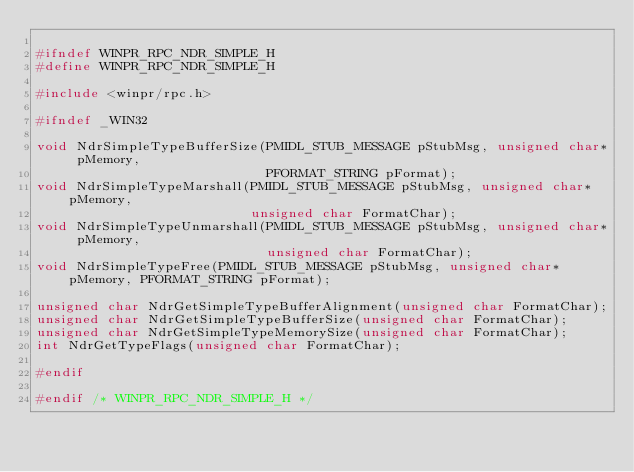<code> <loc_0><loc_0><loc_500><loc_500><_C_>
#ifndef WINPR_RPC_NDR_SIMPLE_H
#define WINPR_RPC_NDR_SIMPLE_H

#include <winpr/rpc.h>

#ifndef _WIN32

void NdrSimpleTypeBufferSize(PMIDL_STUB_MESSAGE pStubMsg, unsigned char* pMemory,
                             PFORMAT_STRING pFormat);
void NdrSimpleTypeMarshall(PMIDL_STUB_MESSAGE pStubMsg, unsigned char* pMemory,
                           unsigned char FormatChar);
void NdrSimpleTypeUnmarshall(PMIDL_STUB_MESSAGE pStubMsg, unsigned char* pMemory,
                             unsigned char FormatChar);
void NdrSimpleTypeFree(PMIDL_STUB_MESSAGE pStubMsg, unsigned char* pMemory, PFORMAT_STRING pFormat);

unsigned char NdrGetSimpleTypeBufferAlignment(unsigned char FormatChar);
unsigned char NdrGetSimpleTypeBufferSize(unsigned char FormatChar);
unsigned char NdrGetSimpleTypeMemorySize(unsigned char FormatChar);
int NdrGetTypeFlags(unsigned char FormatChar);

#endif

#endif /* WINPR_RPC_NDR_SIMPLE_H */
</code> 